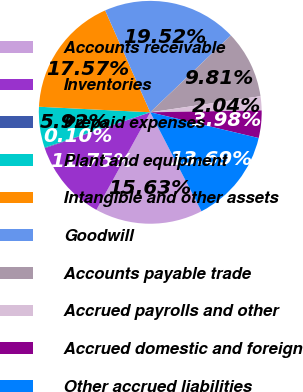Convert chart to OTSL. <chart><loc_0><loc_0><loc_500><loc_500><pie_chart><fcel>Accounts receivable<fcel>Inventories<fcel>Prepaid expenses<fcel>Plant and equipment<fcel>Intangible and other assets<fcel>Goodwill<fcel>Accounts payable trade<fcel>Accrued payrolls and other<fcel>Accrued domestic and foreign<fcel>Other accrued liabilities<nl><fcel>15.63%<fcel>11.75%<fcel>0.1%<fcel>5.92%<fcel>17.57%<fcel>19.52%<fcel>9.81%<fcel>2.04%<fcel>3.98%<fcel>13.69%<nl></chart> 